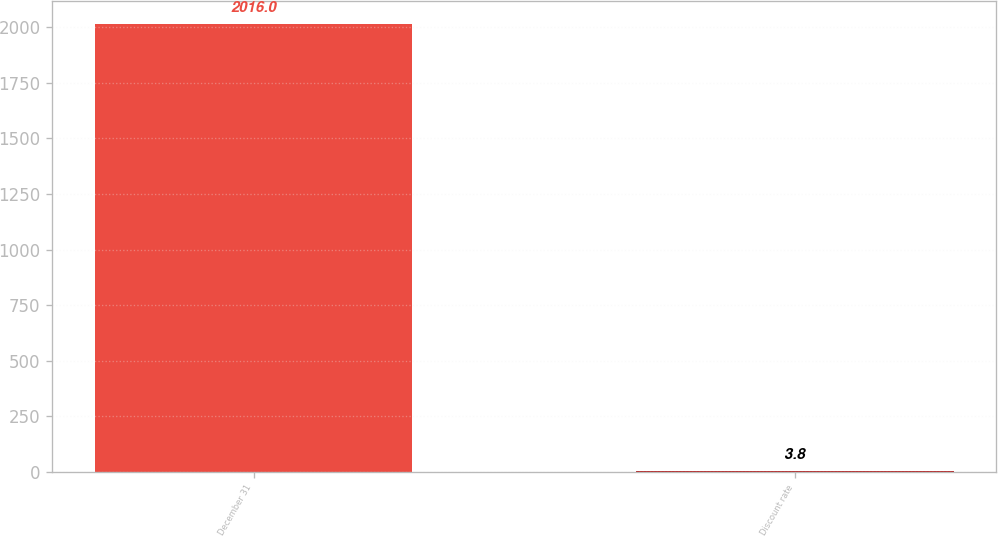<chart> <loc_0><loc_0><loc_500><loc_500><bar_chart><fcel>December 31<fcel>Discount rate<nl><fcel>2016<fcel>3.8<nl></chart> 